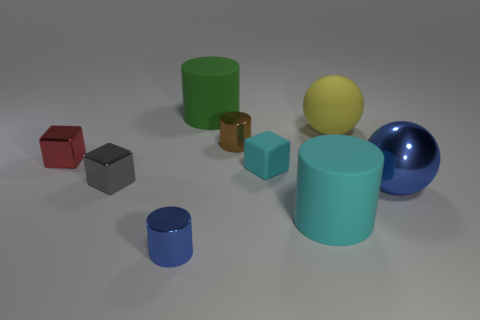There is a cyan cylinder that is the same material as the cyan block; what size is it?
Your response must be concise. Large. What shape is the big rubber object that is both to the right of the brown cylinder and behind the tiny gray block?
Make the answer very short. Sphere. How big is the blue object to the right of the shiny cylinder that is behind the big blue metal ball?
Offer a very short reply. Large. How many other objects are there of the same color as the rubber ball?
Keep it short and to the point. 0. What material is the cyan block?
Ensure brevity in your answer.  Rubber. Are there any large blue things?
Your response must be concise. Yes. Are there the same number of green cylinders that are on the left side of the tiny blue cylinder and big red things?
Provide a succinct answer. Yes. How many tiny things are blue metal cylinders or red matte cylinders?
Your answer should be very brief. 1. There is a metallic object that is the same color as the shiny ball; what shape is it?
Provide a short and direct response. Cylinder. Is the tiny thing that is in front of the blue shiny ball made of the same material as the large yellow thing?
Your response must be concise. No. 